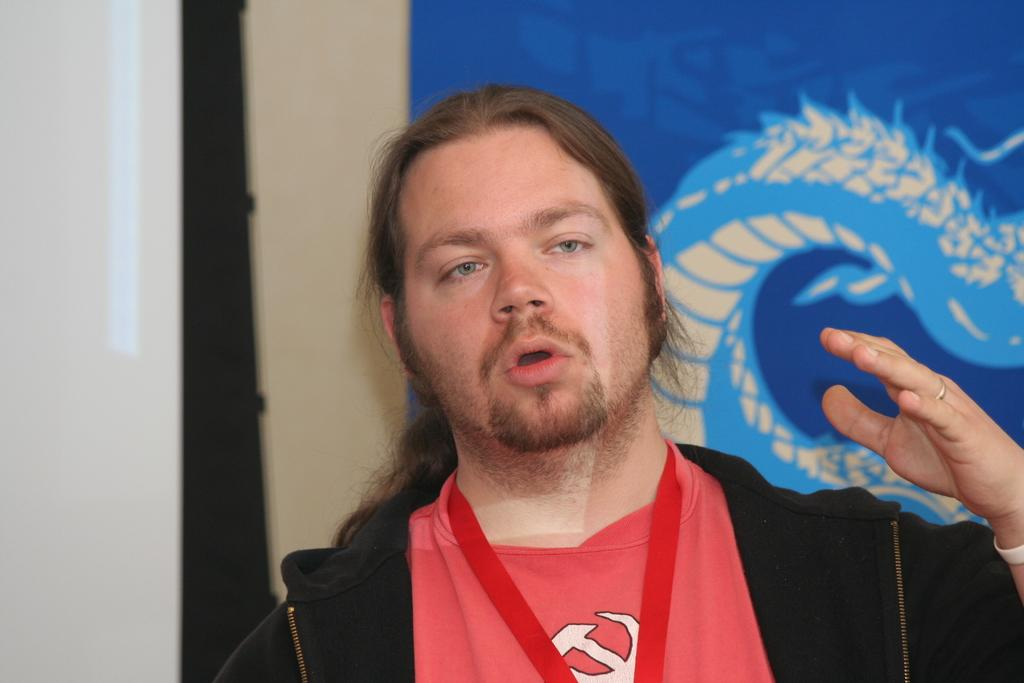What can be seen in the image? There is a person in the image. What is the person wearing? The person is wearing a black color jacket. Are there any accessories visible on the person? Yes, the person is wearing a ring. What is the person doing in the image? The person is speaking. What can be seen in the background of the image? There is a violet color banner, a screen, and a wall in the background. Can you see a notebook on the person's desk in the image? There is no desk or notebook present in the image. Is the person in jail in the image? There is no indication of a jail or any confinement in the image. 